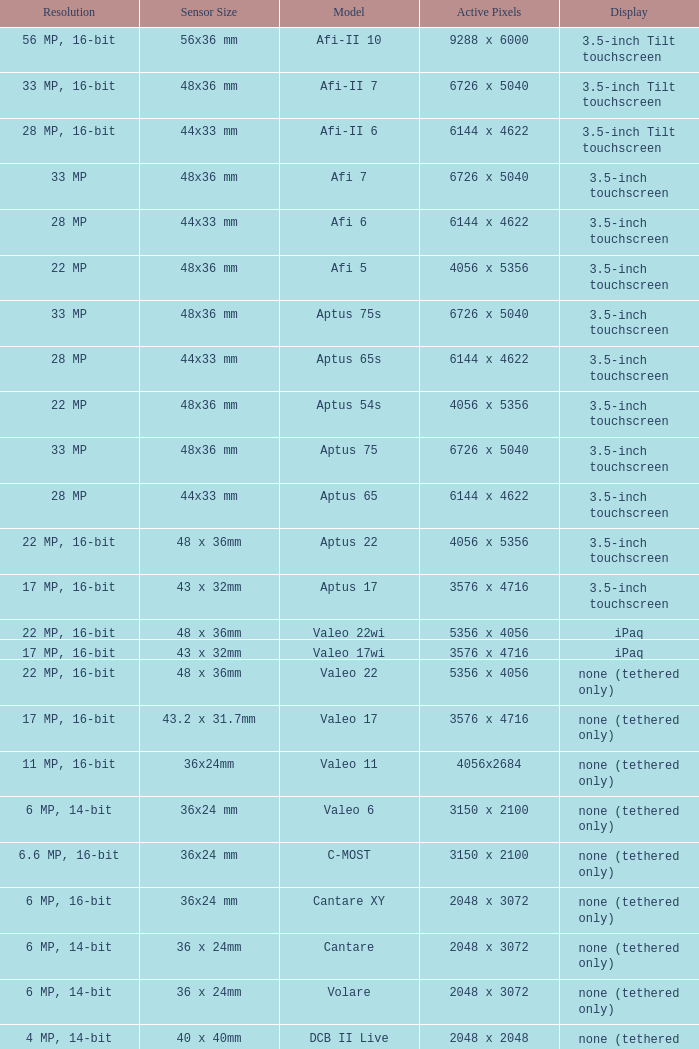What are the active pixels of the c-most model camera? 3150 x 2100. 